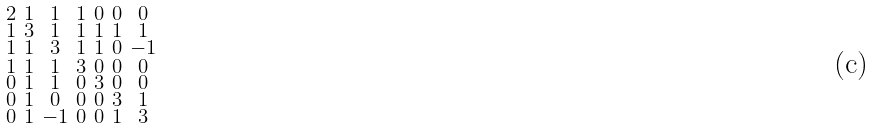<formula> <loc_0><loc_0><loc_500><loc_500>\begin{smallmatrix} 2 & 1 & 1 & 1 & 0 & 0 & 0 \\ 1 & 3 & 1 & 1 & 1 & 1 & 1 \\ 1 & 1 & 3 & 1 & 1 & 0 & - 1 \\ 1 & 1 & 1 & 3 & 0 & 0 & 0 \\ 0 & 1 & 1 & 0 & 3 & 0 & 0 \\ 0 & 1 & 0 & 0 & 0 & 3 & 1 \\ 0 & 1 & - 1 & 0 & 0 & 1 & 3 \end{smallmatrix}</formula> 